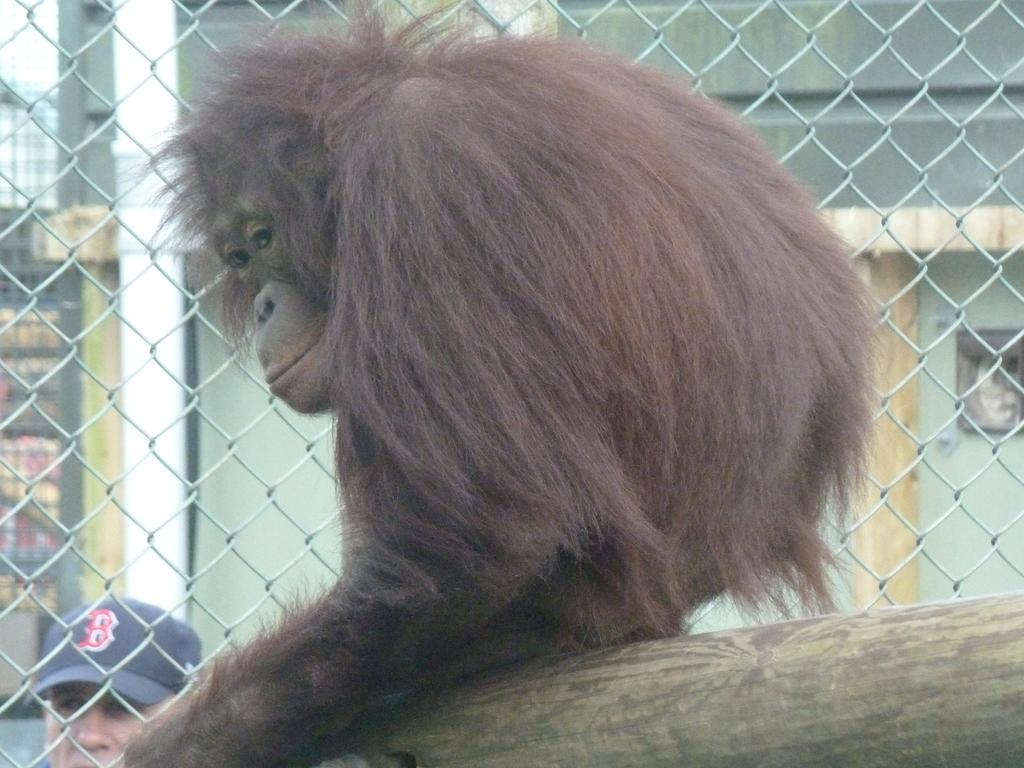What type of animal is in the image? There is an animal in the image, but its specific type cannot be determined from the provided facts. Can you describe the color of the animal? The animal is brown and black in color. Where is the animal located in the image? The animal is on a wooden log. What else can be seen in the image? There is metal fencing and a person in the image. What is visible in the background of the image? There are buildings and the sky visible in the background of the image. What type of grass is the animal eating in the image? There is no grass present in the image, and the animal's actions cannot be determined from the provided facts. What type of authority figure is present in the image? There is no mention of an authority figure in the provided facts, so it cannot be determined if one is present in the image. 